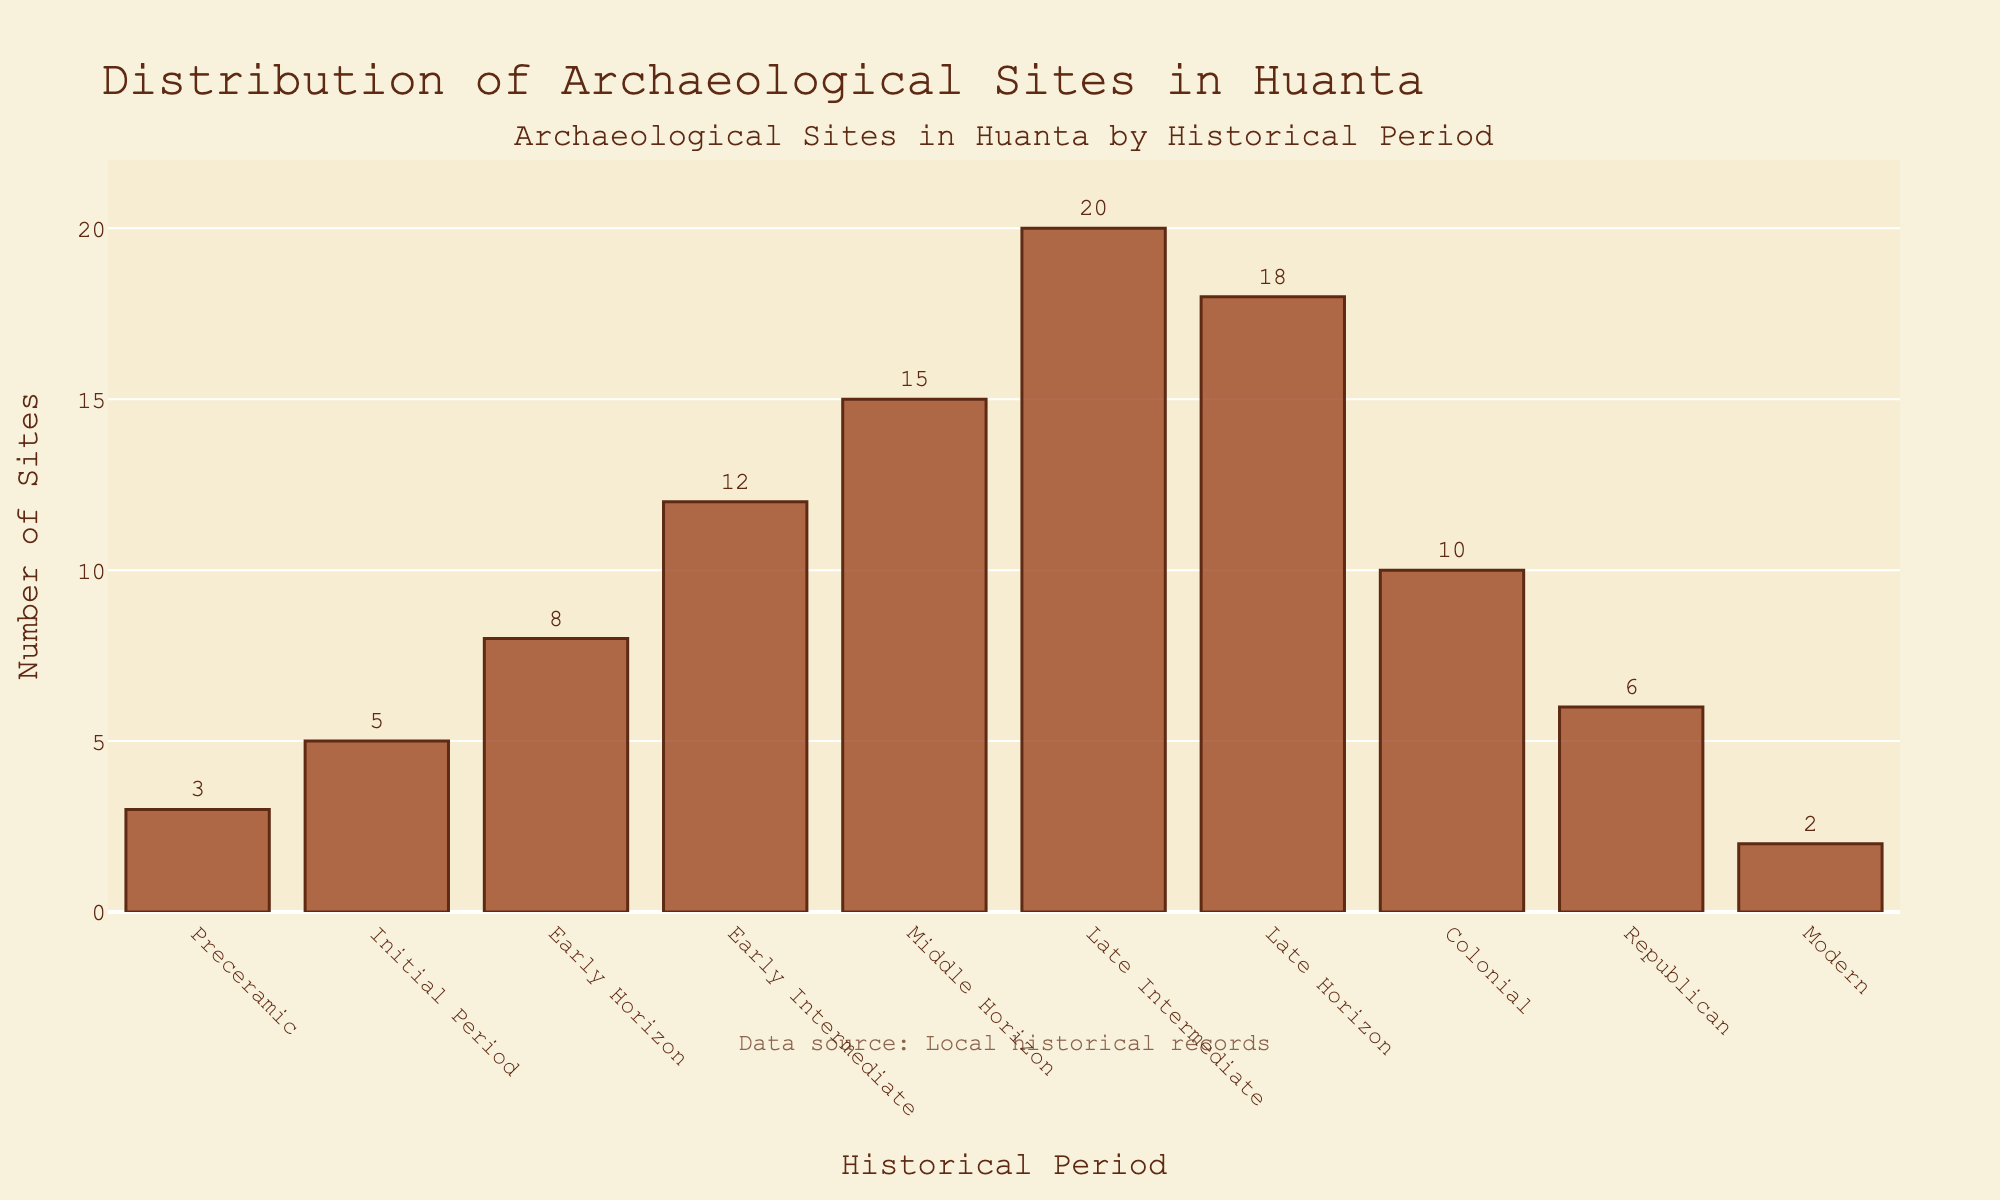Which period has the highest number of archaeological sites? The bar for the Late Intermediate period is the tallest in the figure, indicating it has the highest number of sites.
Answer: Late Intermediate How many more archaeological sites are there in the Late Horizon period compared to the Preceramic period? The number of sites in the Late Horizon is 18, and in the Preceramic period, it is 3. The difference is 18 - 3.
Answer: 15 Which periods have an equal number of archaeological sites? The figure shows that none of the bars representing the number of archaeological sites are of equal height.
Answer: None What is the total number of sites from the Early Intermediate, Middle Horizon, and Late Horizon periods? Sum the numbers of sites: Early Intermediate (12) + Middle Horizon (15) + Late Horizon (18) = 45.
Answer: 45 How does the number of sites in the Colonial period compare to the Republican period? The Colonial period has 10 sites, and the Republican period has 6 sites. 10 is greater than 6.
Answer: Colonial period has more sites What is the average number of sites for the Early Horizon and Initial periods? Sum of sites for Early Horizon (8) and Initial Period (5) is 13. The average is 13 / 2.
Answer: 6.5 Which period follows the Early Intermediate period in terms of the number of sites? The Early Intermediate period has 12 sites and the next higher bar represents the Middle Horizon with 15 sites.
Answer: Middle Horizon What is the ratio of the number of sites in the Late Intermediate period to the Modern period? The Late Intermediate period has 20 sites and the Modern period has 2. The ratio is 20:2.
Answer: 10:1 Which periods have fewer than 5 archaeological sites? The bars representing Preceramic with 3 sites and Modern with 2 sites are shorter than the 5-site mark.
Answer: Preceramic, Modern By how much did the number of sites increase from the Preceramic period to the Early Horizon period? The number of sites in the Preceramic period is 3 and in the Early Horizon period is 8. The increase is 8 - 3.
Answer: 5 